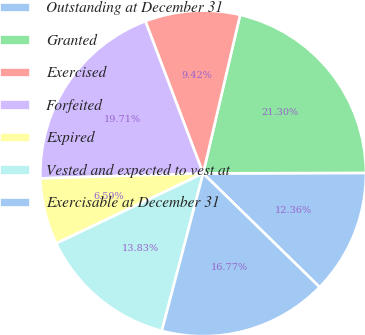Convert chart to OTSL. <chart><loc_0><loc_0><loc_500><loc_500><pie_chart><fcel>Outstanding at December 31<fcel>Granted<fcel>Exercised<fcel>Forfeited<fcel>Expired<fcel>Vested and expected to vest at<fcel>Exercisable at December 31<nl><fcel>12.36%<fcel>21.3%<fcel>9.42%<fcel>19.71%<fcel>6.59%<fcel>13.83%<fcel>16.77%<nl></chart> 